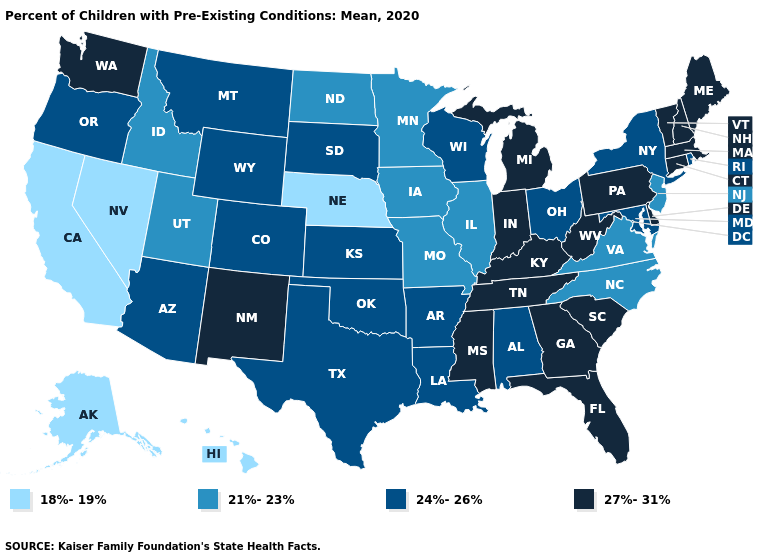What is the highest value in the USA?
Concise answer only. 27%-31%. What is the lowest value in the USA?
Short answer required. 18%-19%. What is the lowest value in states that border Louisiana?
Give a very brief answer. 24%-26%. Does Iowa have a lower value than New York?
Keep it brief. Yes. Does California have the lowest value in the USA?
Concise answer only. Yes. What is the highest value in the USA?
Short answer required. 27%-31%. Name the states that have a value in the range 24%-26%?
Concise answer only. Alabama, Arizona, Arkansas, Colorado, Kansas, Louisiana, Maryland, Montana, New York, Ohio, Oklahoma, Oregon, Rhode Island, South Dakota, Texas, Wisconsin, Wyoming. What is the lowest value in the Northeast?
Quick response, please. 21%-23%. Name the states that have a value in the range 27%-31%?
Be succinct. Connecticut, Delaware, Florida, Georgia, Indiana, Kentucky, Maine, Massachusetts, Michigan, Mississippi, New Hampshire, New Mexico, Pennsylvania, South Carolina, Tennessee, Vermont, Washington, West Virginia. Does Nevada have a higher value than Texas?
Answer briefly. No. Does the map have missing data?
Give a very brief answer. No. What is the highest value in states that border Oklahoma?
Concise answer only. 27%-31%. What is the value of South Carolina?
Answer briefly. 27%-31%. Does Nebraska have the lowest value in the MidWest?
Quick response, please. Yes. Does Nebraska have the lowest value in the USA?
Be succinct. Yes. 